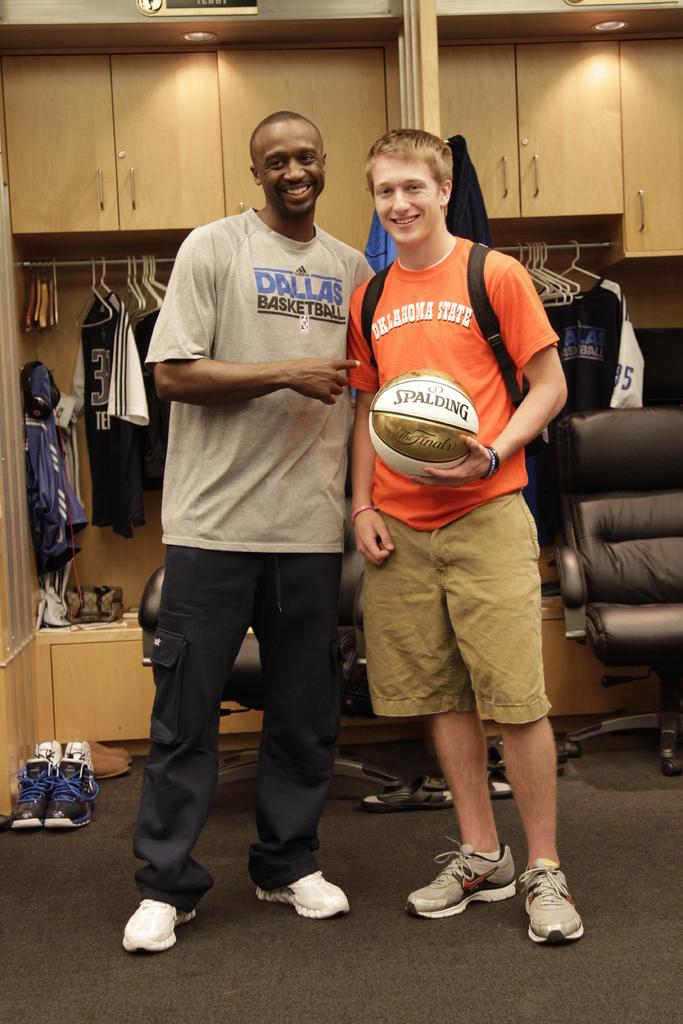Provide a one-sentence caption for the provided image. Two men, one wearing a Dallas basketball T-shirt, the other wearing an Oklahoma State T-shirt and holding a Spalding basket ball, are standing together. 